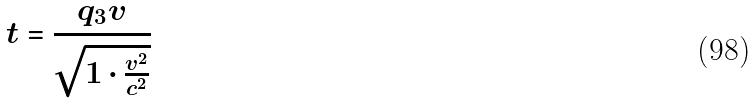Convert formula to latex. <formula><loc_0><loc_0><loc_500><loc_500>t = \frac { q _ { 3 } v } { \sqrt { 1 \cdot \frac { v ^ { 2 } } { c ^ { 2 } } } }</formula> 